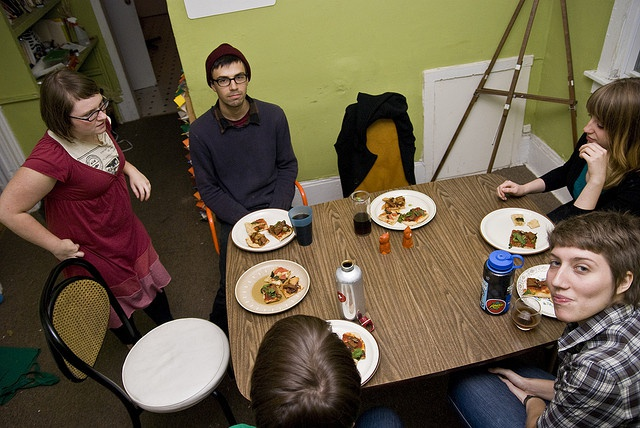Describe the objects in this image and their specific colors. I can see dining table in black, gray, lightgray, and tan tones, people in black, maroon, gray, and tan tones, people in black, gray, darkgray, and tan tones, chair in black, lightgray, olive, and maroon tones, and people in black, gray, and maroon tones in this image. 